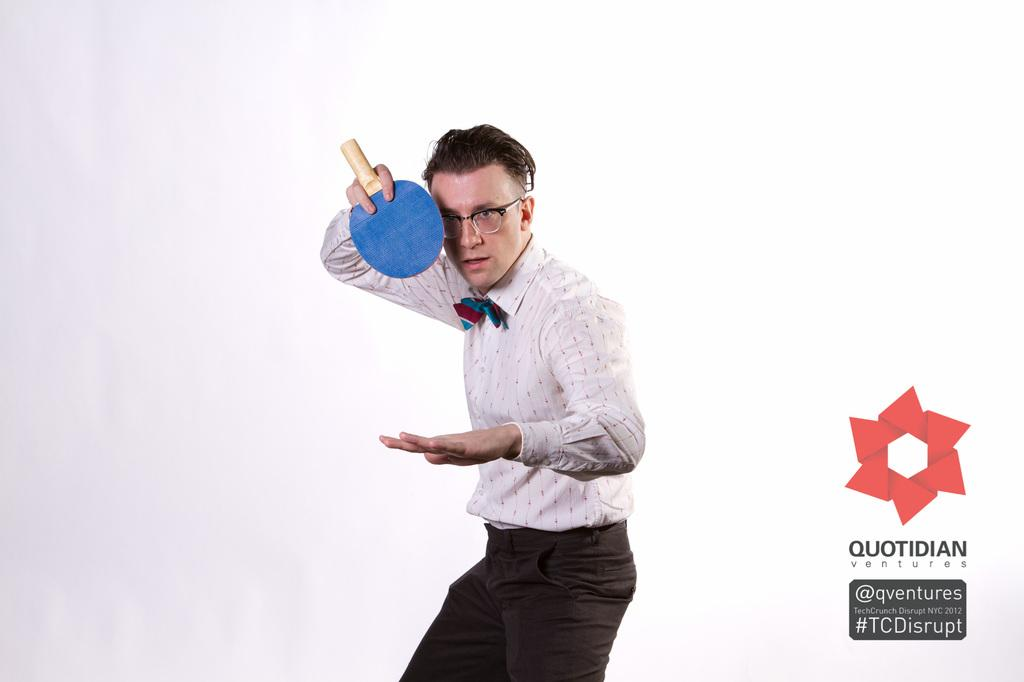Who is present in the image? There is a man in the image. What is the man wearing? The man is wearing a white shirt. Are there any additional details about the white shirt? Yes, the white shirt has a ribbon on it. What can be seen on the man's face? The man is wearing spectacles. What is the man holding in the image? The man is holding a table tennis bat. What else can be seen in the image? There is a poster in the image. What type of flowers can be seen in the drawer in the image? There is no drawer or flowers present in the image. 